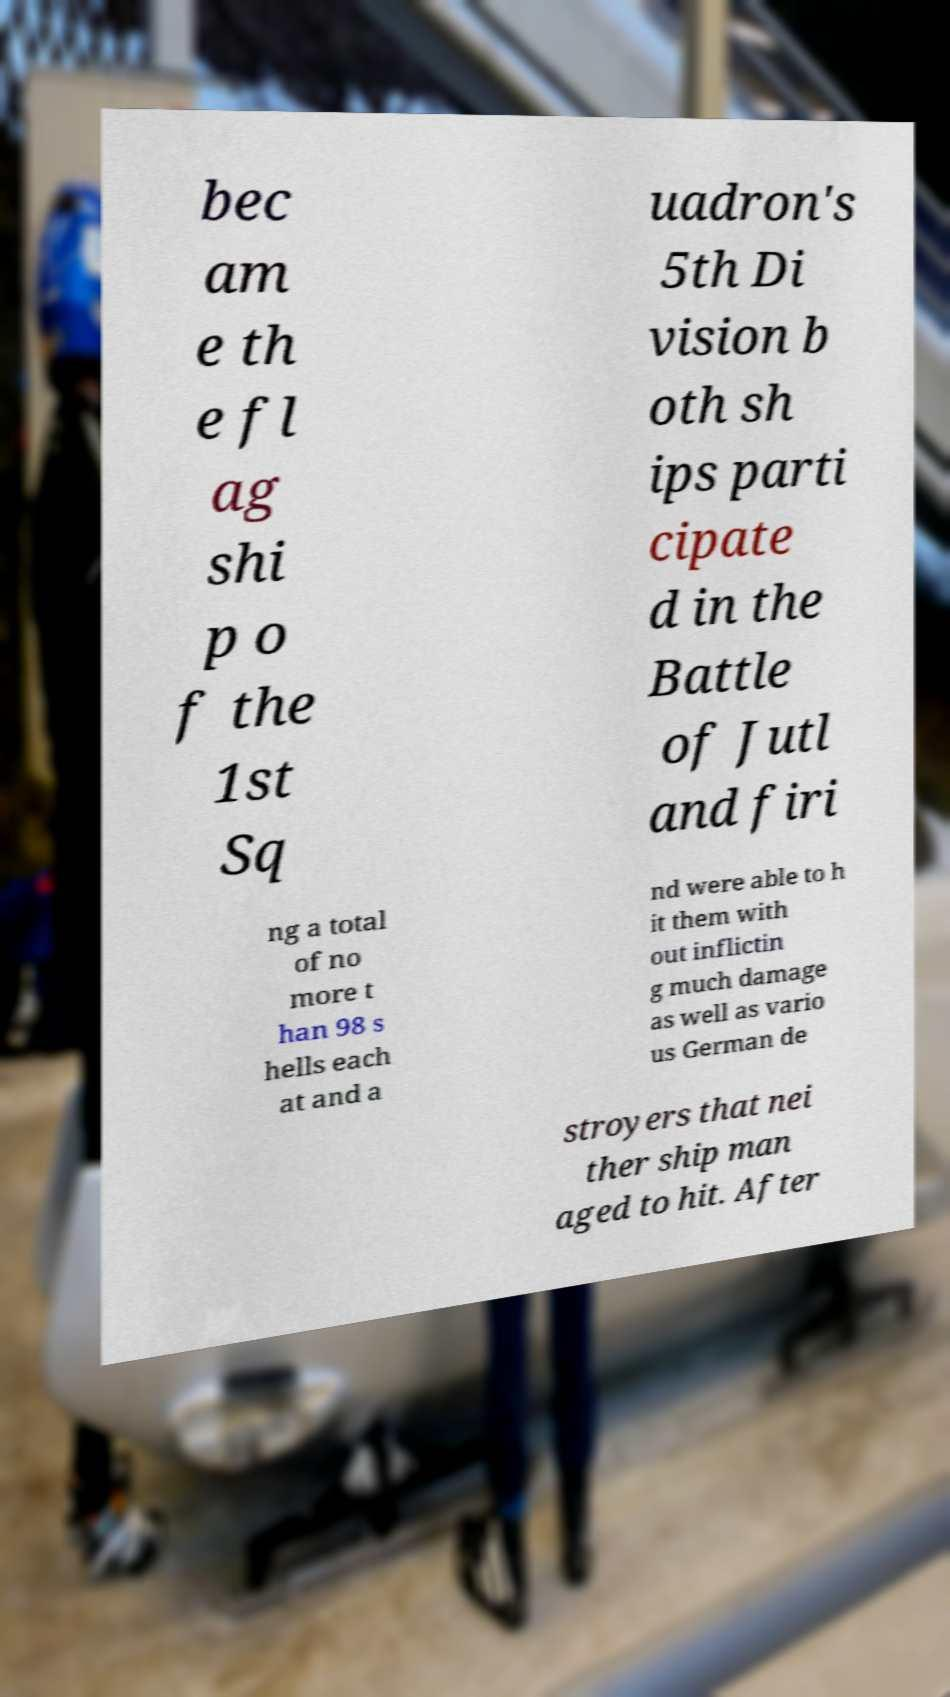There's text embedded in this image that I need extracted. Can you transcribe it verbatim? bec am e th e fl ag shi p o f the 1st Sq uadron's 5th Di vision b oth sh ips parti cipate d in the Battle of Jutl and firi ng a total of no more t han 98 s hells each at and a nd were able to h it them with out inflictin g much damage as well as vario us German de stroyers that nei ther ship man aged to hit. After 